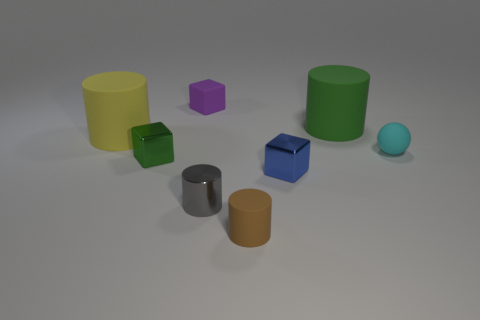Subtract all tiny blue cubes. How many cubes are left? 2 Add 1 gray shiny cylinders. How many objects exist? 9 Subtract all green cylinders. How many cylinders are left? 3 Subtract all balls. How many objects are left? 7 Subtract all yellow blocks. Subtract all red cylinders. How many blocks are left? 3 Subtract all green cubes. How many brown cylinders are left? 1 Subtract all large yellow cylinders. Subtract all red shiny blocks. How many objects are left? 7 Add 7 gray metallic cylinders. How many gray metallic cylinders are left? 8 Add 3 green cylinders. How many green cylinders exist? 4 Subtract 1 brown cylinders. How many objects are left? 7 